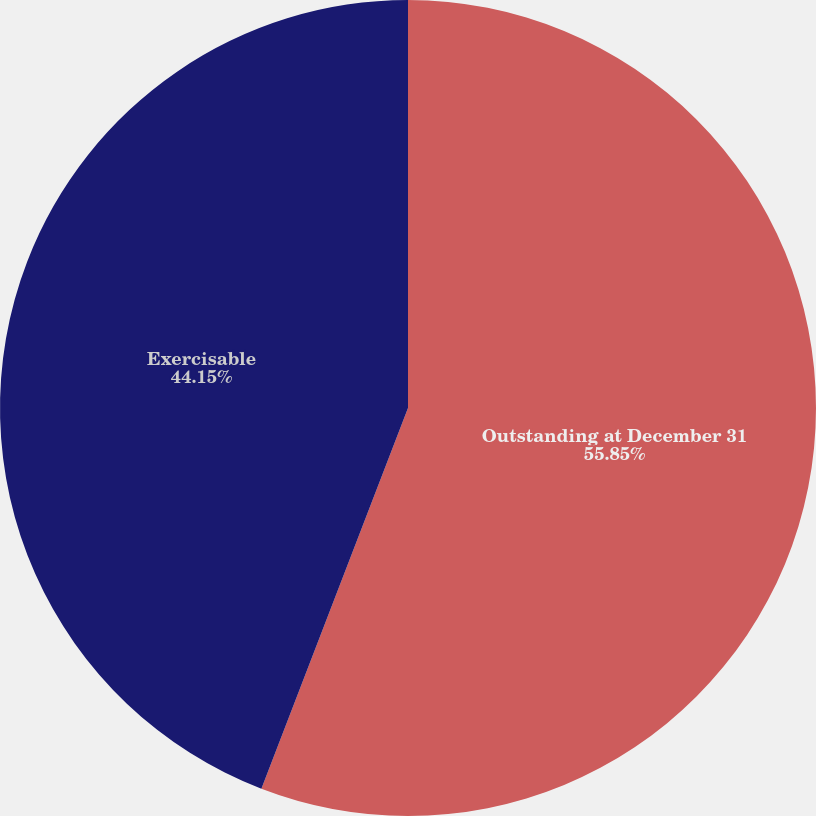<chart> <loc_0><loc_0><loc_500><loc_500><pie_chart><fcel>Outstanding at December 31<fcel>Exercisable<nl><fcel>55.85%<fcel>44.15%<nl></chart> 